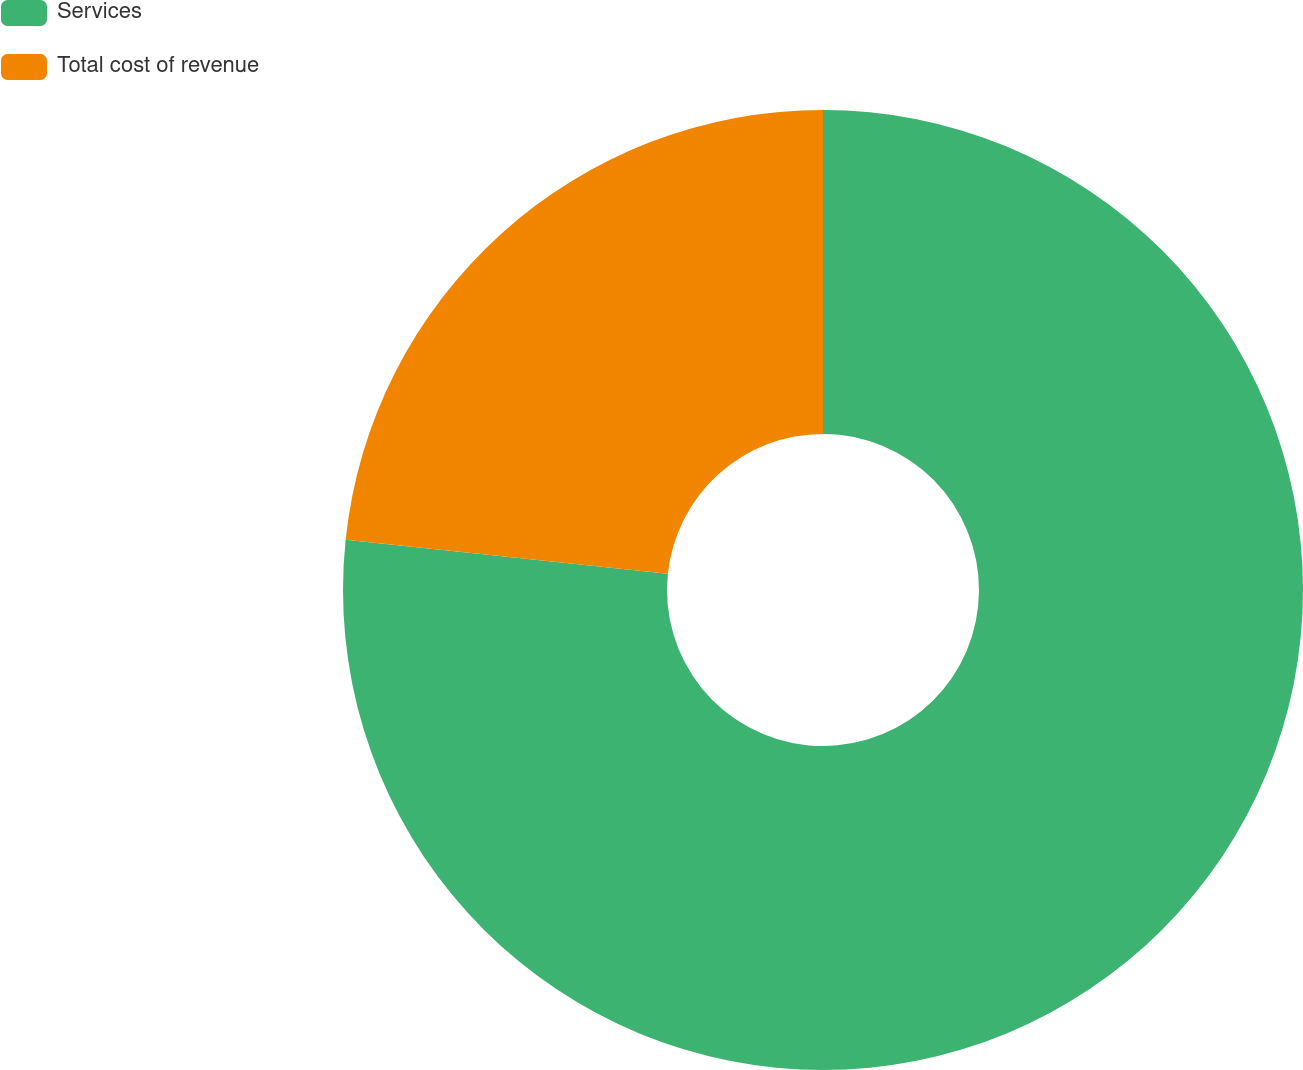Convert chart to OTSL. <chart><loc_0><loc_0><loc_500><loc_500><pie_chart><fcel>Services<fcel>Total cost of revenue<nl><fcel>76.67%<fcel>23.33%<nl></chart> 